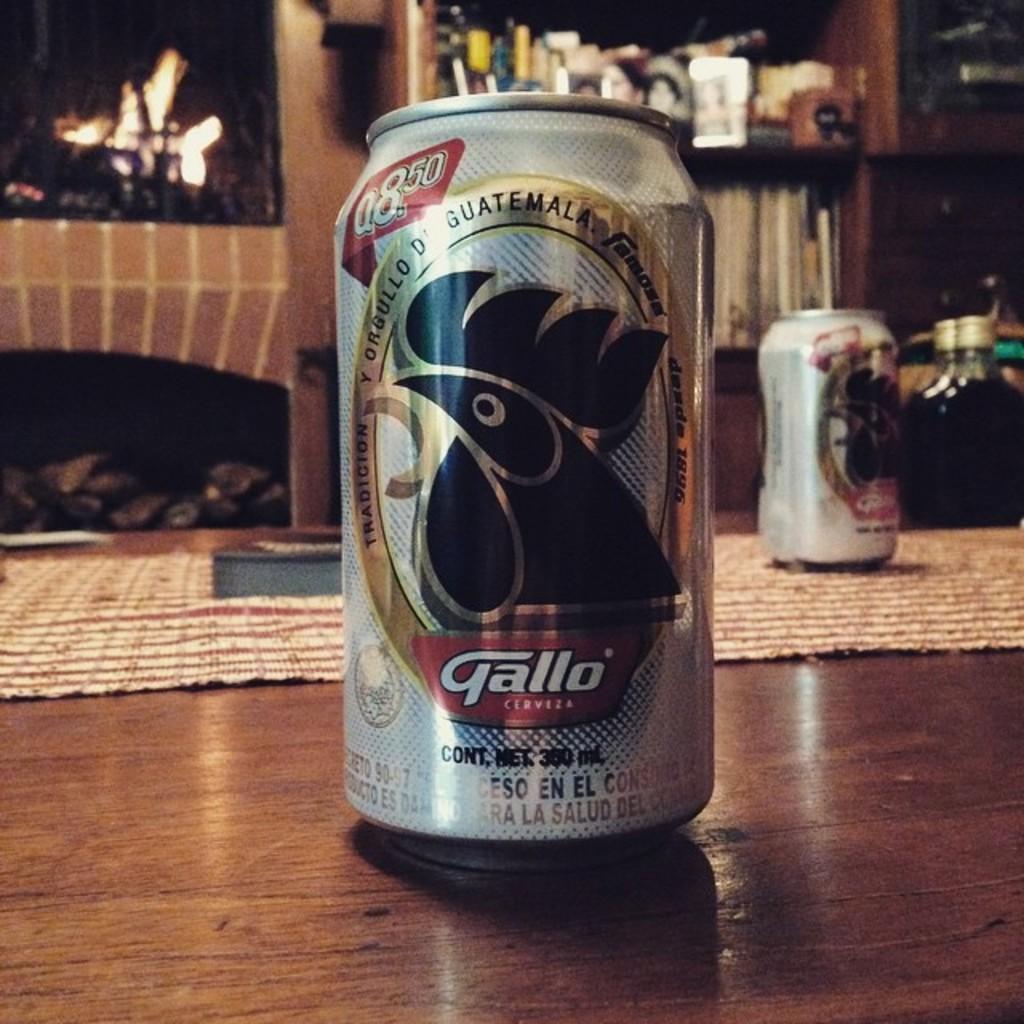Could you give a brief overview of what you see in this image? This image consists of a tin kept on the floor. At the bottom, there is a floor made up of wood. In the background, there is a fireplace. To the right, there is a rack in which books are kept. 